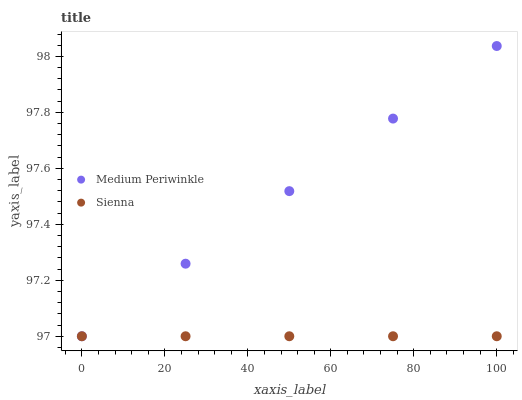Does Sienna have the minimum area under the curve?
Answer yes or no. Yes. Does Medium Periwinkle have the maximum area under the curve?
Answer yes or no. Yes. Does Medium Periwinkle have the minimum area under the curve?
Answer yes or no. No. Is Sienna the smoothest?
Answer yes or no. Yes. Is Medium Periwinkle the roughest?
Answer yes or no. Yes. Does Sienna have the lowest value?
Answer yes or no. Yes. Does Medium Periwinkle have the highest value?
Answer yes or no. Yes. Does Medium Periwinkle intersect Sienna?
Answer yes or no. Yes. Is Medium Periwinkle less than Sienna?
Answer yes or no. No. Is Medium Periwinkle greater than Sienna?
Answer yes or no. No. 